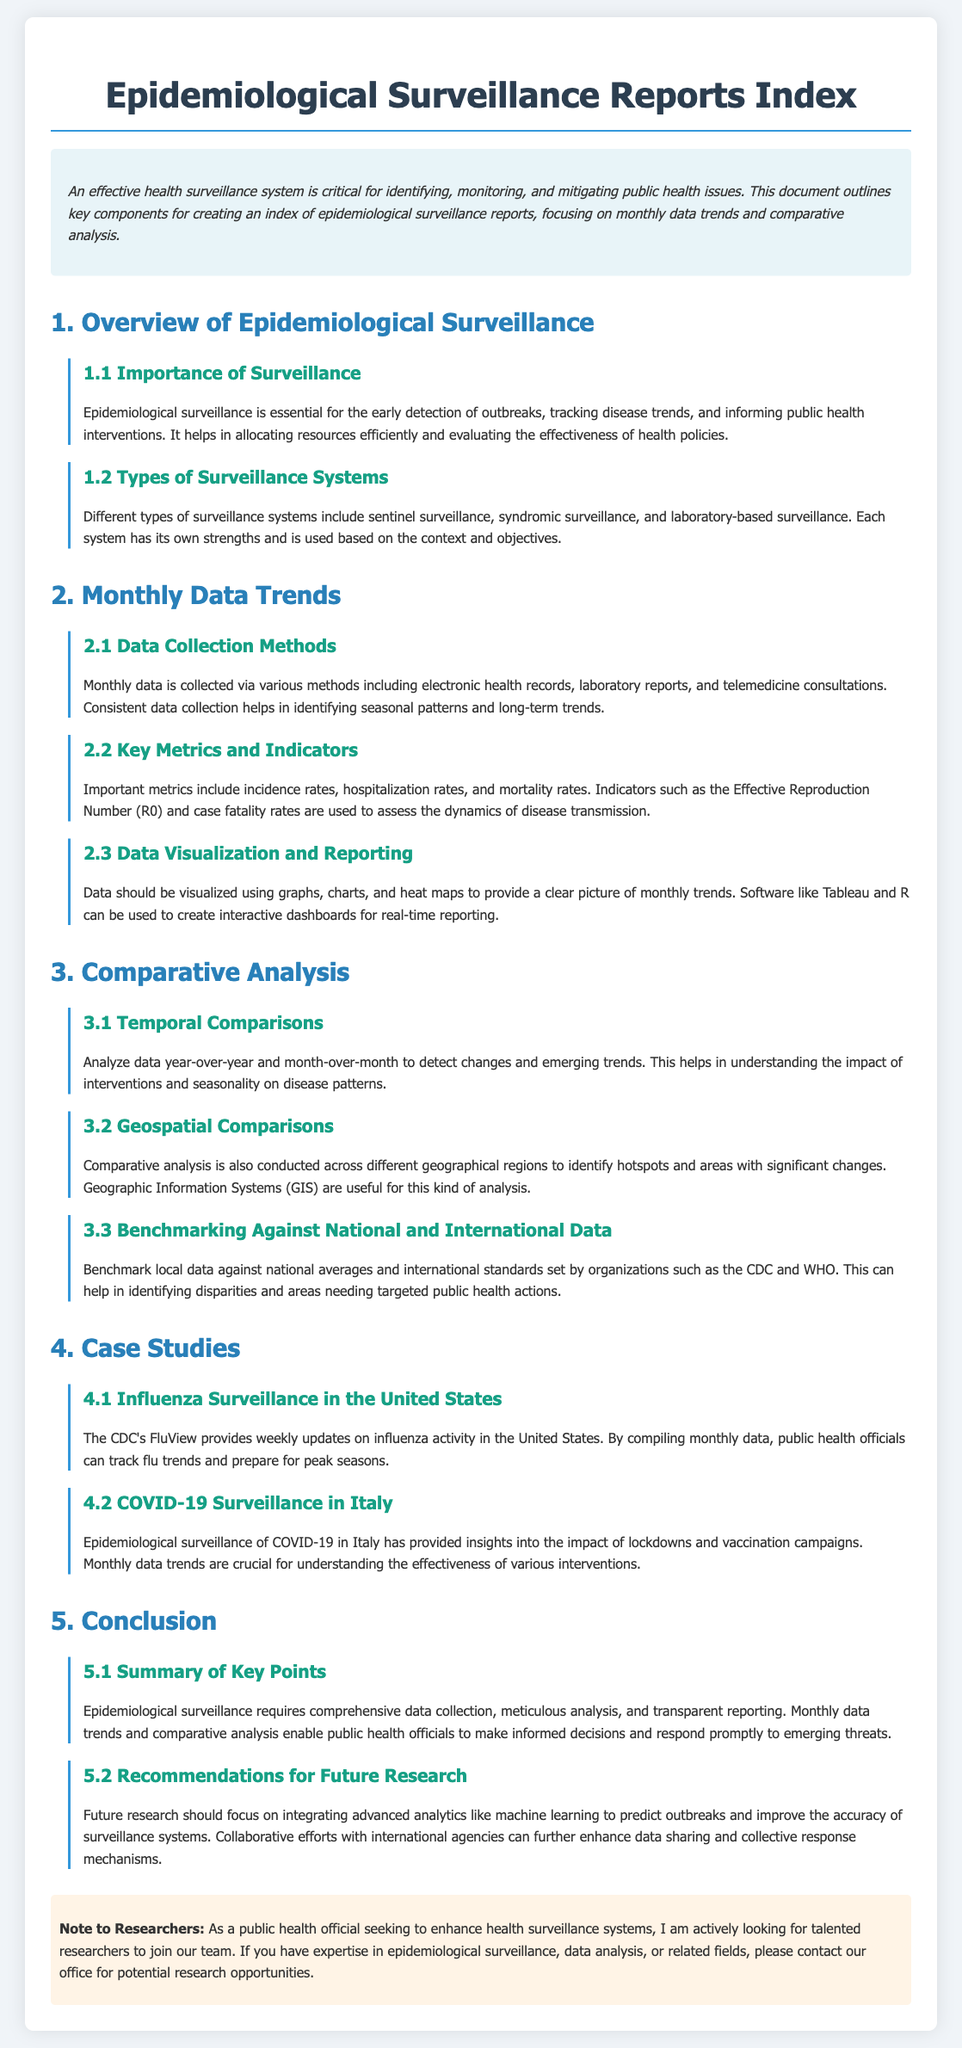What is the main purpose of epidemiological surveillance? The main purpose of epidemiological surveillance is to identify, monitor, and mitigate public health issues.
Answer: identify, monitor, and mitigate public health issues What are the two types of surveillance systems mentioned? The document lists sentinel surveillance and syndromic surveillance as types of surveillance systems.
Answer: sentinel surveillance, syndromic surveillance What are the key metrics used in monthly data analysis? Important metrics include incidence rates, hospitalization rates, and mortality rates.
Answer: incidence rates, hospitalization rates, mortality rates Which software is mentioned for data visualization? The document mentions Tableau and R as software for data visualization.
Answer: Tableau, R What comparative analysis is suggested to identify areas needing public health actions? The document recommends benchmarking local data against national averages and international standards.
Answer: benchmarking against national averages and international standards How often does the CDC's FluView provide updates? The CDC's FluView provides weekly updates on influenza activity.
Answer: weekly What is one area of focus for future research suggested in the document? Future research should focus on integrating advanced analytics like machine learning to predict outbreaks.
Answer: integrating advanced analytics like machine learning What do geographic comparisons help identify? Geographic comparisons help identify hotspots and areas with significant changes.
Answer: hotspots and areas with significant changes What is a key component of effective health surveillance systems? A key component is comprehensive data collection.
Answer: comprehensive data collection 